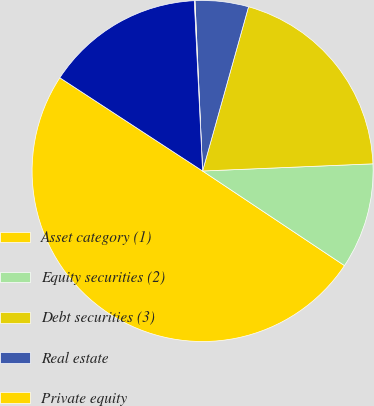Convert chart. <chart><loc_0><loc_0><loc_500><loc_500><pie_chart><fcel>Asset category (1)<fcel>Equity securities (2)<fcel>Debt securities (3)<fcel>Real estate<fcel>Private equity<fcel>Other investments<nl><fcel>49.85%<fcel>10.03%<fcel>19.99%<fcel>5.05%<fcel>0.07%<fcel>15.01%<nl></chart> 